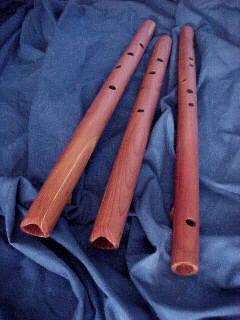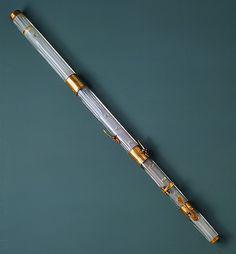The first image is the image on the left, the second image is the image on the right. For the images displayed, is the sentence "One image shows three flutes side by side, with their ends closer together at the top of the image." factually correct? Answer yes or no. Yes. The first image is the image on the left, the second image is the image on the right. Examine the images to the left and right. Is the description "One of the images contains exactly three flutes." accurate? Answer yes or no. Yes. 